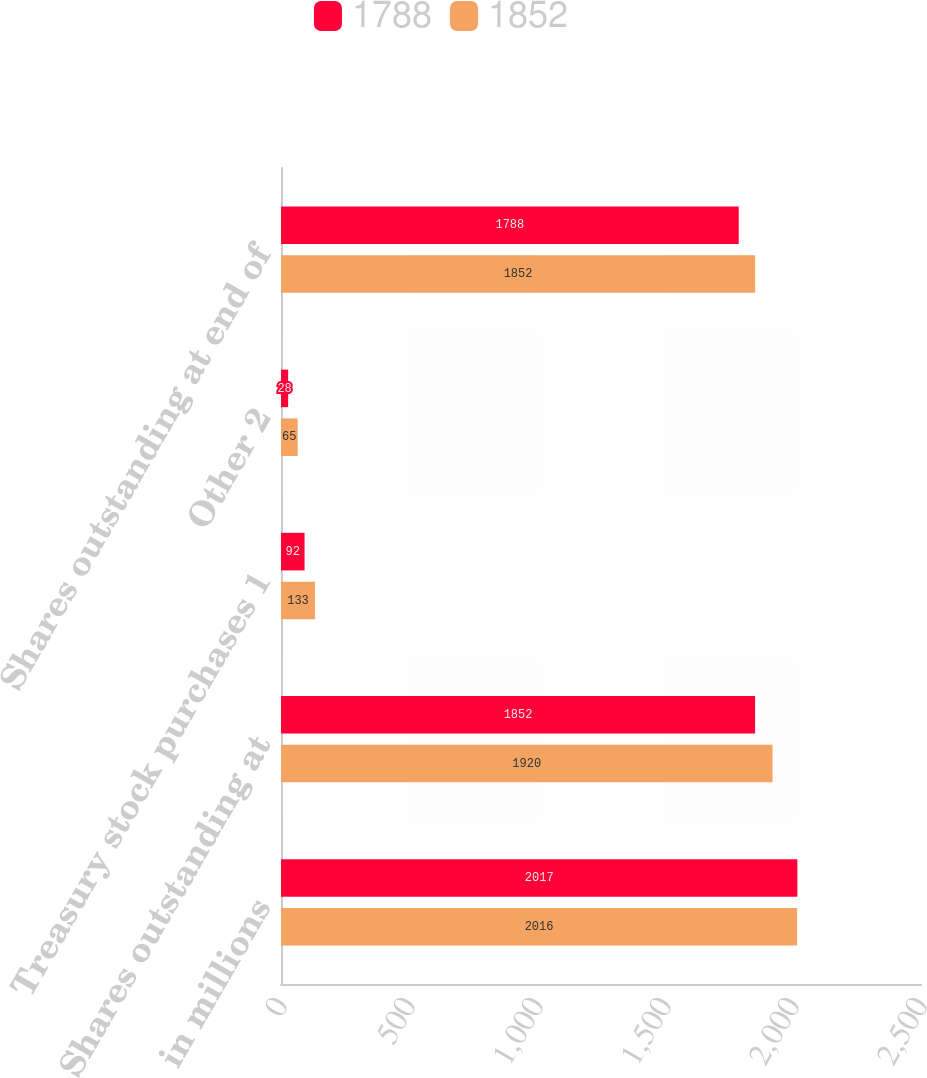Convert chart to OTSL. <chart><loc_0><loc_0><loc_500><loc_500><stacked_bar_chart><ecel><fcel>in millions<fcel>Shares outstanding at<fcel>Treasury stock purchases 1<fcel>Other 2<fcel>Shares outstanding at end of<nl><fcel>1788<fcel>2017<fcel>1852<fcel>92<fcel>28<fcel>1788<nl><fcel>1852<fcel>2016<fcel>1920<fcel>133<fcel>65<fcel>1852<nl></chart> 